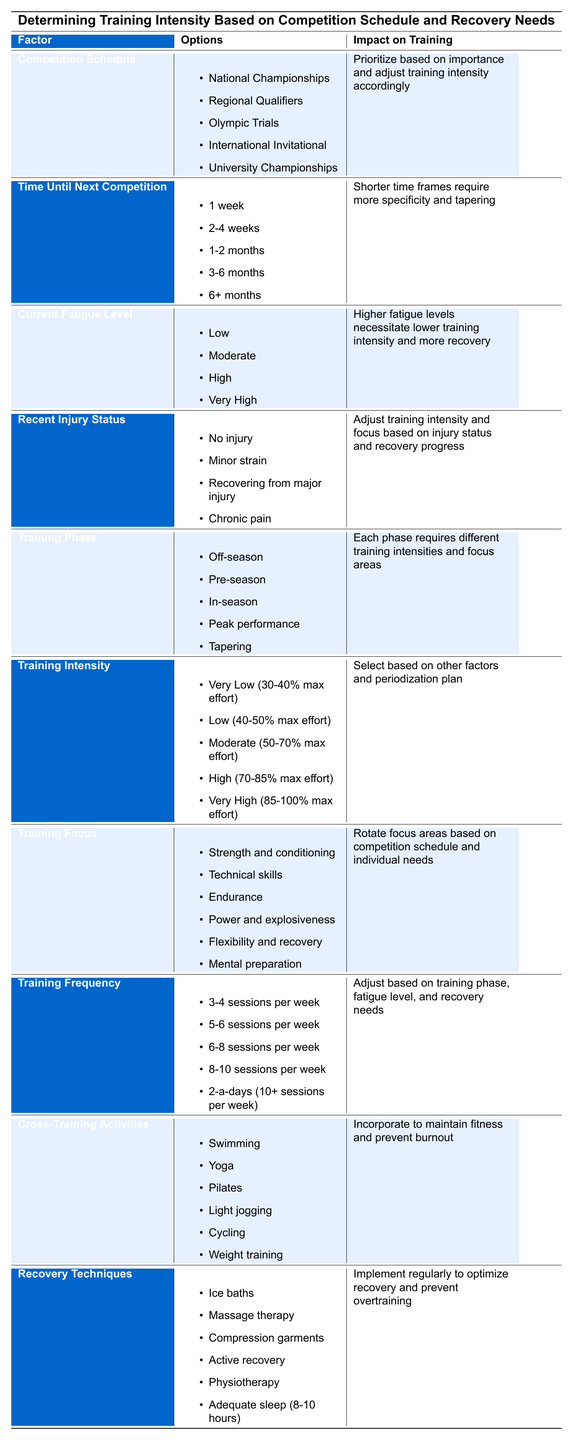What types of recovery techniques are listed in the table? The table lists six recovery techniques: Ice baths, Massage therapy, Compression garments, Active recovery, Physiotherapy, and Adequate sleep (8-10 hours).
Answer: Ice baths, Massage therapy, Compression garments, Active recovery, Physiotherapy, Adequate sleep (8-10 hours) Is the impact of time until the next competition related to the training intensity? Yes, the table states that shorter time frames require more specificity and tapering, which implies a reduction in training intensity as the competition approaches.
Answer: Yes What factors affect training frequency, according to the table? The table indicates that training frequency should be adjusted based on training phase, fatigue level, and recovery needs.
Answer: Training phase, fatigue level, recovery needs If the current fatigue level is very high, what intensity should the training focus on? The table suggests that higher fatigue levels necessitate lower training intensity and more recovery, indicating that the training should be at a Very Low or Low intensity.
Answer: Very Low or Low intensity What is the training focus during the peak performance phase? The table does not specify a single focus for peak performance but suggests that different training focuses are required at each phase, likely prioritizing specific skills needed for competition.
Answer: Not explicitly stated If an athlete has chronic pain, should they train with very high intensity? No, the table indicates that chronic pain may require adjustments in training intensity and focus to lower levels to accommodate recovery.
Answer: No What is the average training intensity range suggested for moderate training? The table states that moderate training intensity is defined as 50-70% max effort. To find the average, we would sum the lower and upper limits (50 + 70) and divide by 2, resulting in an average of 60%.
Answer: 60% Can you combine strength and conditioning with flexibility and recovery in a single training focus? Yes, the table allows rotation of focus areas based on competition schedule and individual needs, so combining these two areas is possible depending on the athlete's priorities.
Answer: Yes What is the impact of the training phase on training intensity? The table specifies that each training phase requires different intensities and focus areas, meaning the phase directly influences how intense the training should be.
Answer: Different intensities required per phase 